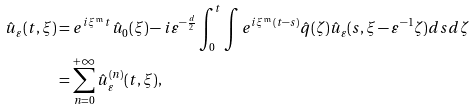Convert formula to latex. <formula><loc_0><loc_0><loc_500><loc_500>\hat { u } _ { \varepsilon } ( t , \xi ) & = e ^ { i \xi ^ { \mathfrak { m } } t } \hat { u } _ { 0 } ( \xi ) - i \varepsilon ^ { - \frac { d } { 2 } } \int _ { 0 } ^ { t } \int e ^ { i \xi ^ { \mathfrak { m } } ( t - s ) } \hat { q } ( \zeta ) \hat { u } _ { \varepsilon } ( s , \xi - \varepsilon ^ { - 1 } \zeta ) d s d \zeta \\ & = \sum _ { n = 0 } ^ { + \infty } \hat { u } _ { \varepsilon } ^ { ( n ) } ( t , \xi ) ,</formula> 